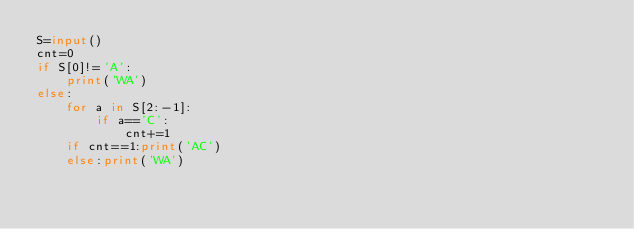<code> <loc_0><loc_0><loc_500><loc_500><_Python_>S=input()
cnt=0
if S[0]!='A':
    print('WA')
else:
    for a in S[2:-1]:
        if a=='C':
            cnt+=1
    if cnt==1:print('AC')
    else:print('WA')</code> 